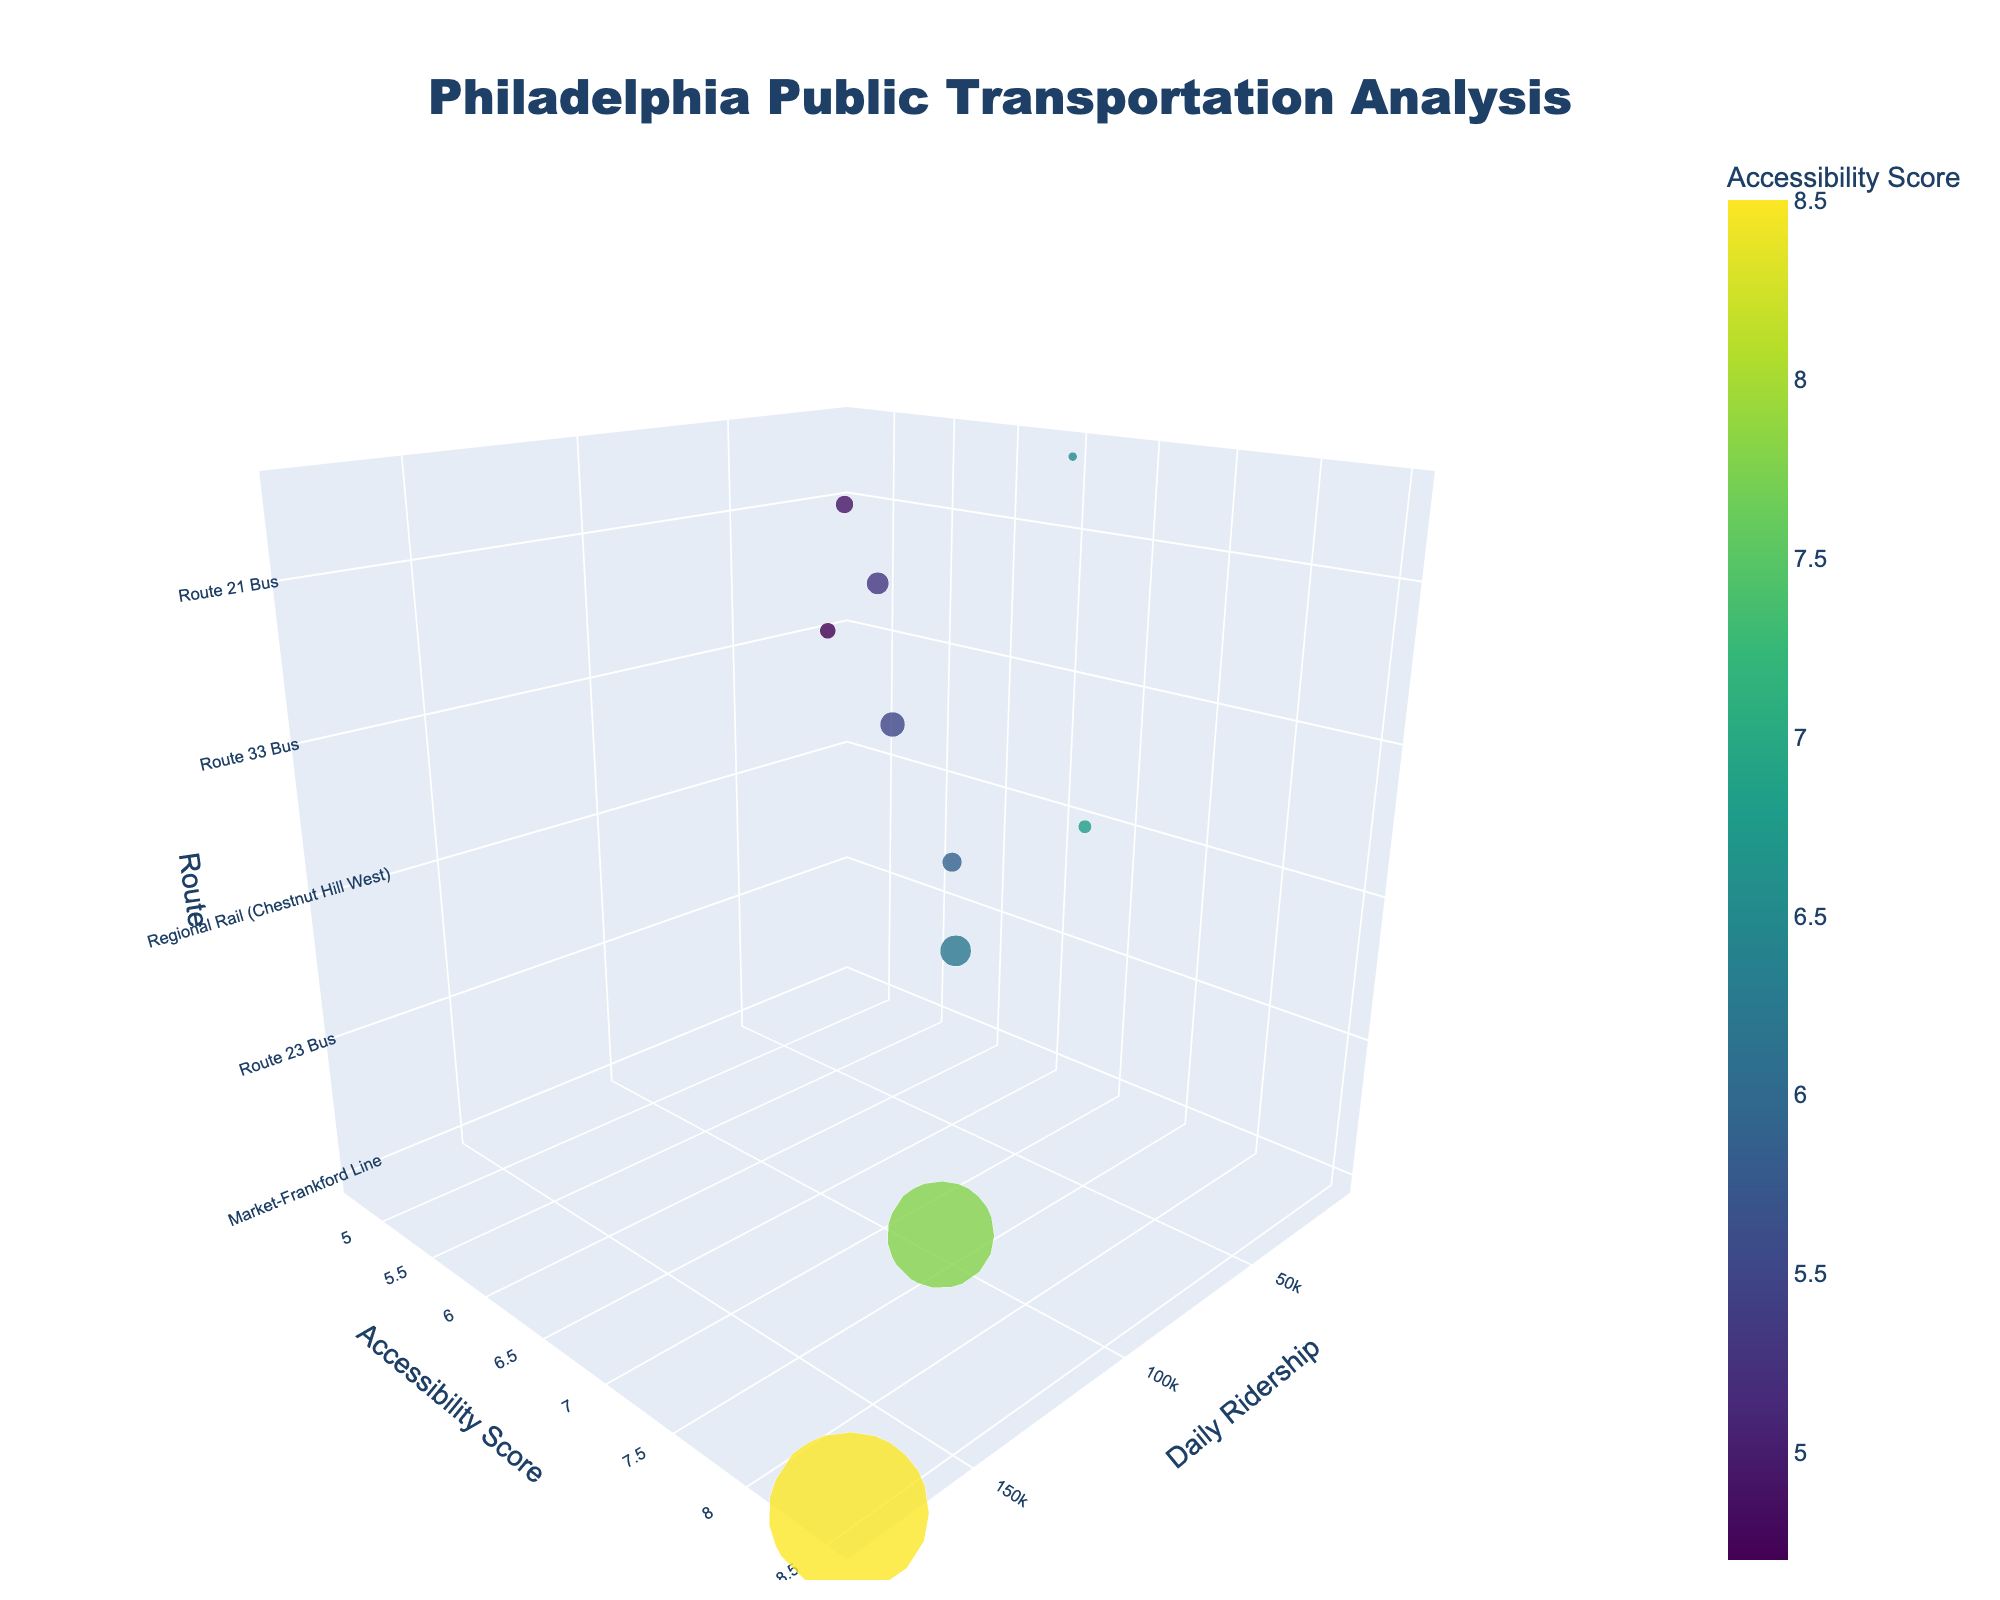What is the title of the chart? The title of the chart is typically displayed prominently at the top of the figure. In this case, it reads "Philadelphia Public Transportation Analysis".
Answer: Philadelphia Public Transportation Analysis Which route has the highest daily ridership? To determine the route with the highest daily ridership, look for the largest bubble along the x-axis. The "Market-Frankford Line" stands out with a daily ridership of 180,000.
Answer: Market-Frankford Line What is the accessibility score for the Broad Street Line? To find the accessibility score for the Broad Street Line, locate the bubble corresponding to this route and check its position on the y-axis. The chart shows an accessibility score of 7.8.
Answer: 7.8 Which route has the lowest accessibility score, and what is its value? The lowest accessibility score can be found by looking at the lowest point along the y-axis. The Route 33 Bus in Strawberry Mansion has the lowest score with a value of 4.7.
Answer: Route 33 Bus, 4.7 How does the daily ridership of the Route 21 Bus compare to the Route 60 Bus? Compare the positions of the bubbles for Route 21 Bus and Route 60 Bus on the x-axis. The Route 21 Bus has a daily ridership of 20,000, while the Route 60 Bus has 25,000, meaning Route 60 Bus has a higher daily ridership.
Answer: Route 60 Bus has higher ridership Which areas are served by routes with an accessibility score greater than 6.5? Identify the bubbles that are positioned above the 6.5 mark on the y-axis, then check the associated areas. They include Center City (Market-Frankford Line), North Philadelphia (Broad Street Line), Northwest Philadelphia (Regional Rail - Chestnut Hill West), Germantown (Route 23 Bus), and Montgomery County (Norristown High Speed Line).
Answer: Center City, North Philadelphia, Northwest Philadelphia, Germantown, Montgomery County What is the sum of the daily ridership for routes with accessibility scores above 7? First, identify routes with accessibility scores above 7: Market-Frankford Line (180,000), Broad Street Line (120,000). Sum these riderships: 180,000 + 120,000 = 300,000.
Answer: 300,000 Which route has the smallest bubble and what is its daily ridership? The smallest bubble represents the route with the lowest daily ridership. The Norristown High Speed Line has the smallest bubble with a daily ridership of 10,000.
Answer: Norristown High Speed Line, 10,000 What's the average accessibility score of all routes? Calculate the average by summing all accessibility scores and dividing by the number of routes. Scores are: 8.5, 7.8, 6.2, 5.9, 6.8, 5.5, 4.7, 5.3, 4.9, 6.5. Sum is 61.1. Dividing by 10 routes gives 61.1 / 10 = 6.11.
Answer: 6.11 Which route connects to Center City and what's its daily ridership and accessibility score? Locate the bubble showing an area of Center City. The label reads "Market-Frankford Line", which has a daily ridership of 180,000 and an accessibility score of 8.5.
Answer: Market-Frankford Line, 180,000, 8.5 